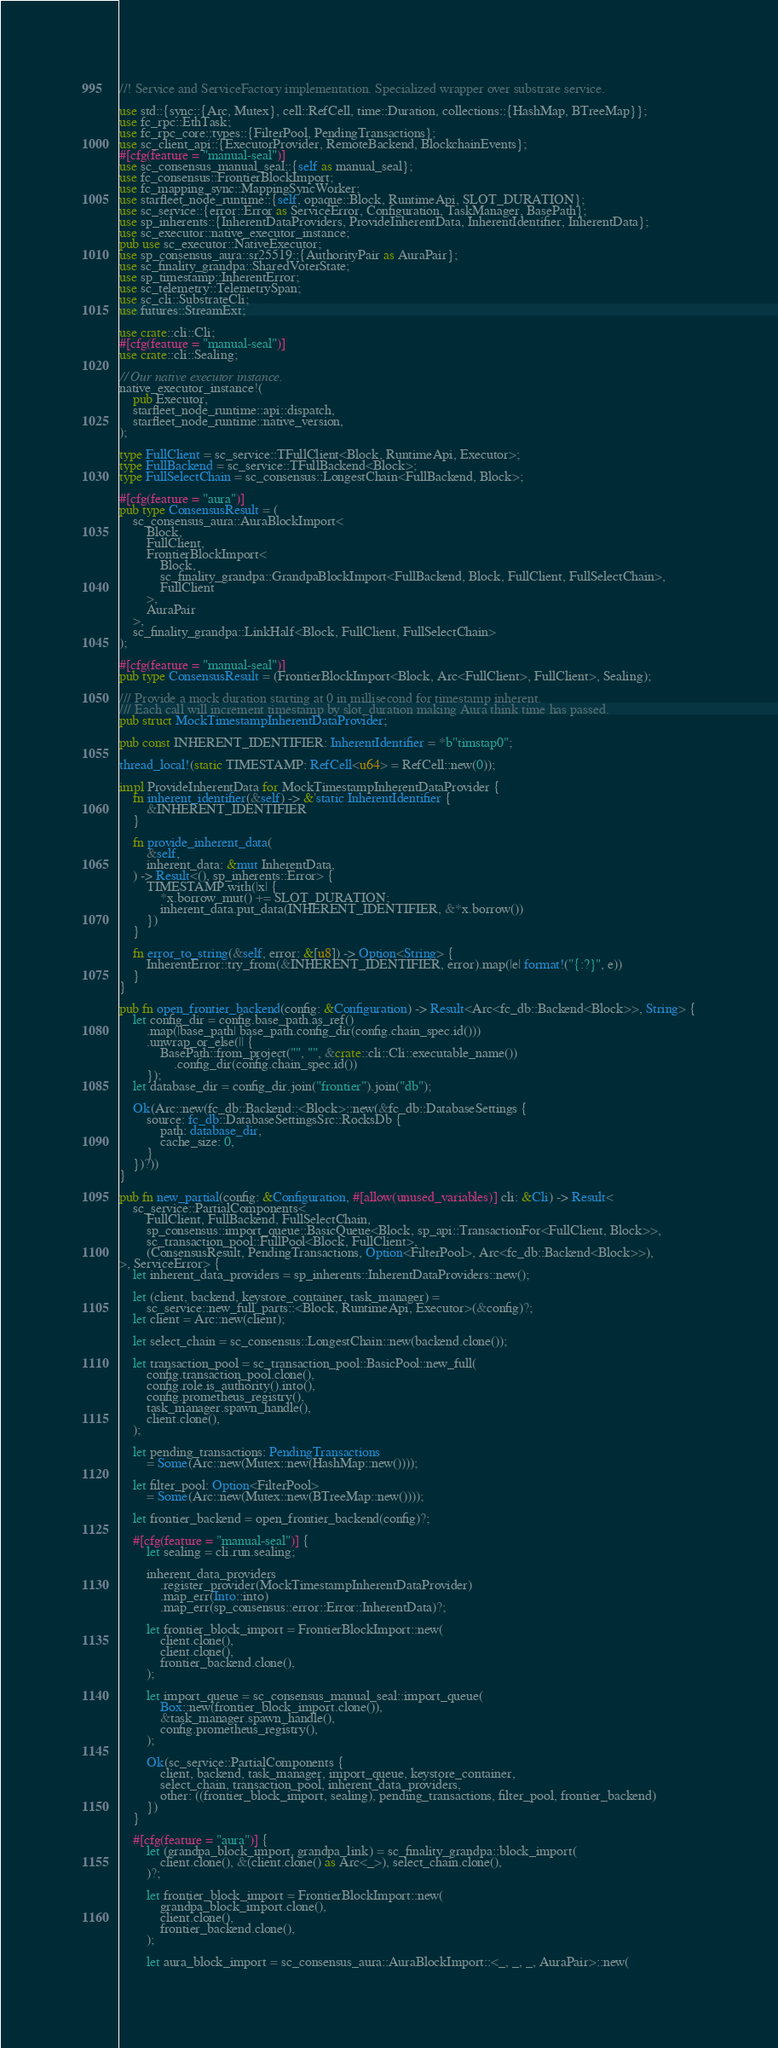<code> <loc_0><loc_0><loc_500><loc_500><_Rust_>//! Service and ServiceFactory implementation. Specialized wrapper over substrate service.

use std::{sync::{Arc, Mutex}, cell::RefCell, time::Duration, collections::{HashMap, BTreeMap}};
use fc_rpc::EthTask;
use fc_rpc_core::types::{FilterPool, PendingTransactions};
use sc_client_api::{ExecutorProvider, RemoteBackend, BlockchainEvents};
#[cfg(feature = "manual-seal")]
use sc_consensus_manual_seal::{self as manual_seal};
use fc_consensus::FrontierBlockImport;
use fc_mapping_sync::MappingSyncWorker;
use starfleet_node_runtime::{self, opaque::Block, RuntimeApi, SLOT_DURATION};
use sc_service::{error::Error as ServiceError, Configuration, TaskManager, BasePath};
use sp_inherents::{InherentDataProviders, ProvideInherentData, InherentIdentifier, InherentData};
use sc_executor::native_executor_instance;
pub use sc_executor::NativeExecutor;
use sp_consensus_aura::sr25519::{AuthorityPair as AuraPair};
use sc_finality_grandpa::SharedVoterState;
use sp_timestamp::InherentError;
use sc_telemetry::TelemetrySpan;
use sc_cli::SubstrateCli;
use futures::StreamExt;

use crate::cli::Cli;
#[cfg(feature = "manual-seal")]
use crate::cli::Sealing;

// Our native executor instance.
native_executor_instance!(
	pub Executor,
	starfleet_node_runtime::api::dispatch,
	starfleet_node_runtime::native_version,
);

type FullClient = sc_service::TFullClient<Block, RuntimeApi, Executor>;
type FullBackend = sc_service::TFullBackend<Block>;
type FullSelectChain = sc_consensus::LongestChain<FullBackend, Block>;

#[cfg(feature = "aura")]
pub type ConsensusResult = (
	sc_consensus_aura::AuraBlockImport<
		Block,
		FullClient,
		FrontierBlockImport<
			Block,
			sc_finality_grandpa::GrandpaBlockImport<FullBackend, Block, FullClient, FullSelectChain>,
			FullClient
		>,
		AuraPair
	>,
	sc_finality_grandpa::LinkHalf<Block, FullClient, FullSelectChain>
);

#[cfg(feature = "manual-seal")]
pub type ConsensusResult = (FrontierBlockImport<Block, Arc<FullClient>, FullClient>, Sealing);

/// Provide a mock duration starting at 0 in millisecond for timestamp inherent.
/// Each call will increment timestamp by slot_duration making Aura think time has passed.
pub struct MockTimestampInherentDataProvider;

pub const INHERENT_IDENTIFIER: InherentIdentifier = *b"timstap0";

thread_local!(static TIMESTAMP: RefCell<u64> = RefCell::new(0));

impl ProvideInherentData for MockTimestampInherentDataProvider {
	fn inherent_identifier(&self) -> &'static InherentIdentifier {
		&INHERENT_IDENTIFIER
	}

	fn provide_inherent_data(
		&self,
		inherent_data: &mut InherentData,
	) -> Result<(), sp_inherents::Error> {
		TIMESTAMP.with(|x| {
			*x.borrow_mut() += SLOT_DURATION;
			inherent_data.put_data(INHERENT_IDENTIFIER, &*x.borrow())
		})
	}

	fn error_to_string(&self, error: &[u8]) -> Option<String> {
		InherentError::try_from(&INHERENT_IDENTIFIER, error).map(|e| format!("{:?}", e))
	}
}

pub fn open_frontier_backend(config: &Configuration) -> Result<Arc<fc_db::Backend<Block>>, String> {
	let config_dir = config.base_path.as_ref()
		.map(|base_path| base_path.config_dir(config.chain_spec.id()))
		.unwrap_or_else(|| {
			BasePath::from_project("", "", &crate::cli::Cli::executable_name())
				.config_dir(config.chain_spec.id())
		});
	let database_dir = config_dir.join("frontier").join("db");

	Ok(Arc::new(fc_db::Backend::<Block>::new(&fc_db::DatabaseSettings {
		source: fc_db::DatabaseSettingsSrc::RocksDb {
			path: database_dir,
			cache_size: 0,
		}
	})?))
}

pub fn new_partial(config: &Configuration, #[allow(unused_variables)] cli: &Cli) -> Result<
	sc_service::PartialComponents<
		FullClient, FullBackend, FullSelectChain,
		sp_consensus::import_queue::BasicQueue<Block, sp_api::TransactionFor<FullClient, Block>>,
		sc_transaction_pool::FullPool<Block, FullClient>,
		(ConsensusResult, PendingTransactions, Option<FilterPool>, Arc<fc_db::Backend<Block>>),
>, ServiceError> {
	let inherent_data_providers = sp_inherents::InherentDataProviders::new();

	let (client, backend, keystore_container, task_manager) =
		sc_service::new_full_parts::<Block, RuntimeApi, Executor>(&config)?;
	let client = Arc::new(client);

	let select_chain = sc_consensus::LongestChain::new(backend.clone());

	let transaction_pool = sc_transaction_pool::BasicPool::new_full(
		config.transaction_pool.clone(),
		config.role.is_authority().into(),
		config.prometheus_registry(),
		task_manager.spawn_handle(),
		client.clone(),
	);

	let pending_transactions: PendingTransactions
		= Some(Arc::new(Mutex::new(HashMap::new())));

	let filter_pool: Option<FilterPool>
		= Some(Arc::new(Mutex::new(BTreeMap::new())));

	let frontier_backend = open_frontier_backend(config)?;

	#[cfg(feature = "manual-seal")] {
		let sealing = cli.run.sealing;

		inherent_data_providers
			.register_provider(MockTimestampInherentDataProvider)
			.map_err(Into::into)
			.map_err(sp_consensus::error::Error::InherentData)?;

		let frontier_block_import = FrontierBlockImport::new(
			client.clone(),
			client.clone(),
			frontier_backend.clone(),
		);

		let import_queue = sc_consensus_manual_seal::import_queue(
			Box::new(frontier_block_import.clone()),
			&task_manager.spawn_handle(),
			config.prometheus_registry(),
		);

		Ok(sc_service::PartialComponents {
			client, backend, task_manager, import_queue, keystore_container,
			select_chain, transaction_pool, inherent_data_providers,
			other: ((frontier_block_import, sealing), pending_transactions, filter_pool, frontier_backend)
		})
	}

	#[cfg(feature = "aura")] {
		let (grandpa_block_import, grandpa_link) = sc_finality_grandpa::block_import(
			client.clone(), &(client.clone() as Arc<_>), select_chain.clone(),
		)?;

		let frontier_block_import = FrontierBlockImport::new(
			grandpa_block_import.clone(),
			client.clone(),
			frontier_backend.clone(),
		);

		let aura_block_import = sc_consensus_aura::AuraBlockImport::<_, _, _, AuraPair>::new(</code> 